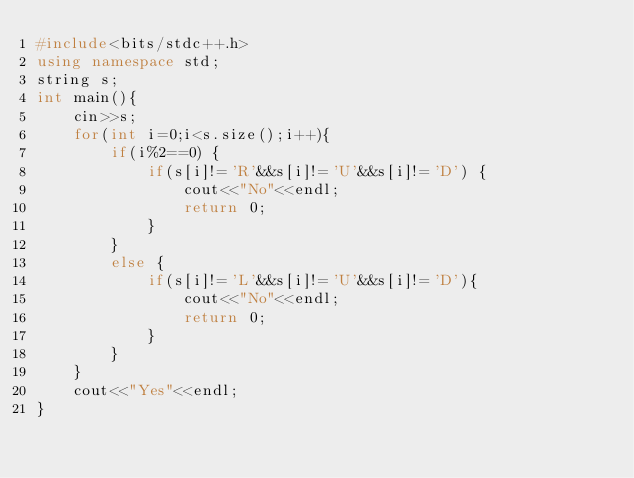<code> <loc_0><loc_0><loc_500><loc_500><_C++_>#include<bits/stdc++.h>
using namespace std;
string s;
int main(){
	cin>>s;
	for(int i=0;i<s.size();i++){
		if(i%2==0) {
			if(s[i]!='R'&&s[i]!='U'&&s[i]!='D') {
				cout<<"No"<<endl;
				return 0;
			}
		}
		else {
			if(s[i]!='L'&&s[i]!='U'&&s[i]!='D'){
				cout<<"No"<<endl;
				return 0;
			}
		}
	}
	cout<<"Yes"<<endl;
}</code> 